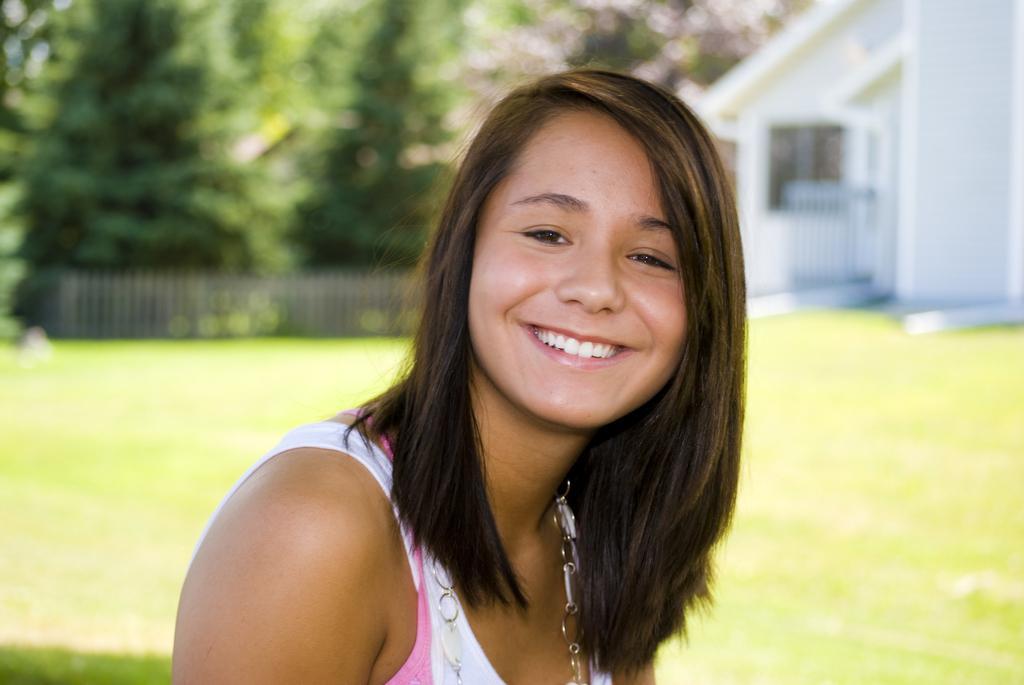In one or two sentences, can you explain what this image depicts? In this image I can see the person with the white and pink color dress. In the background I can see the building, railing and many trees. And the background is blurred. 